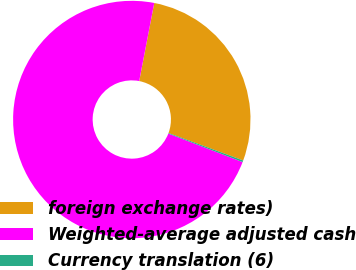Convert chart to OTSL. <chart><loc_0><loc_0><loc_500><loc_500><pie_chart><fcel>foreign exchange rates)<fcel>Weighted-average adjusted cash<fcel>Currency translation (6)<nl><fcel>27.58%<fcel>72.19%<fcel>0.23%<nl></chart> 